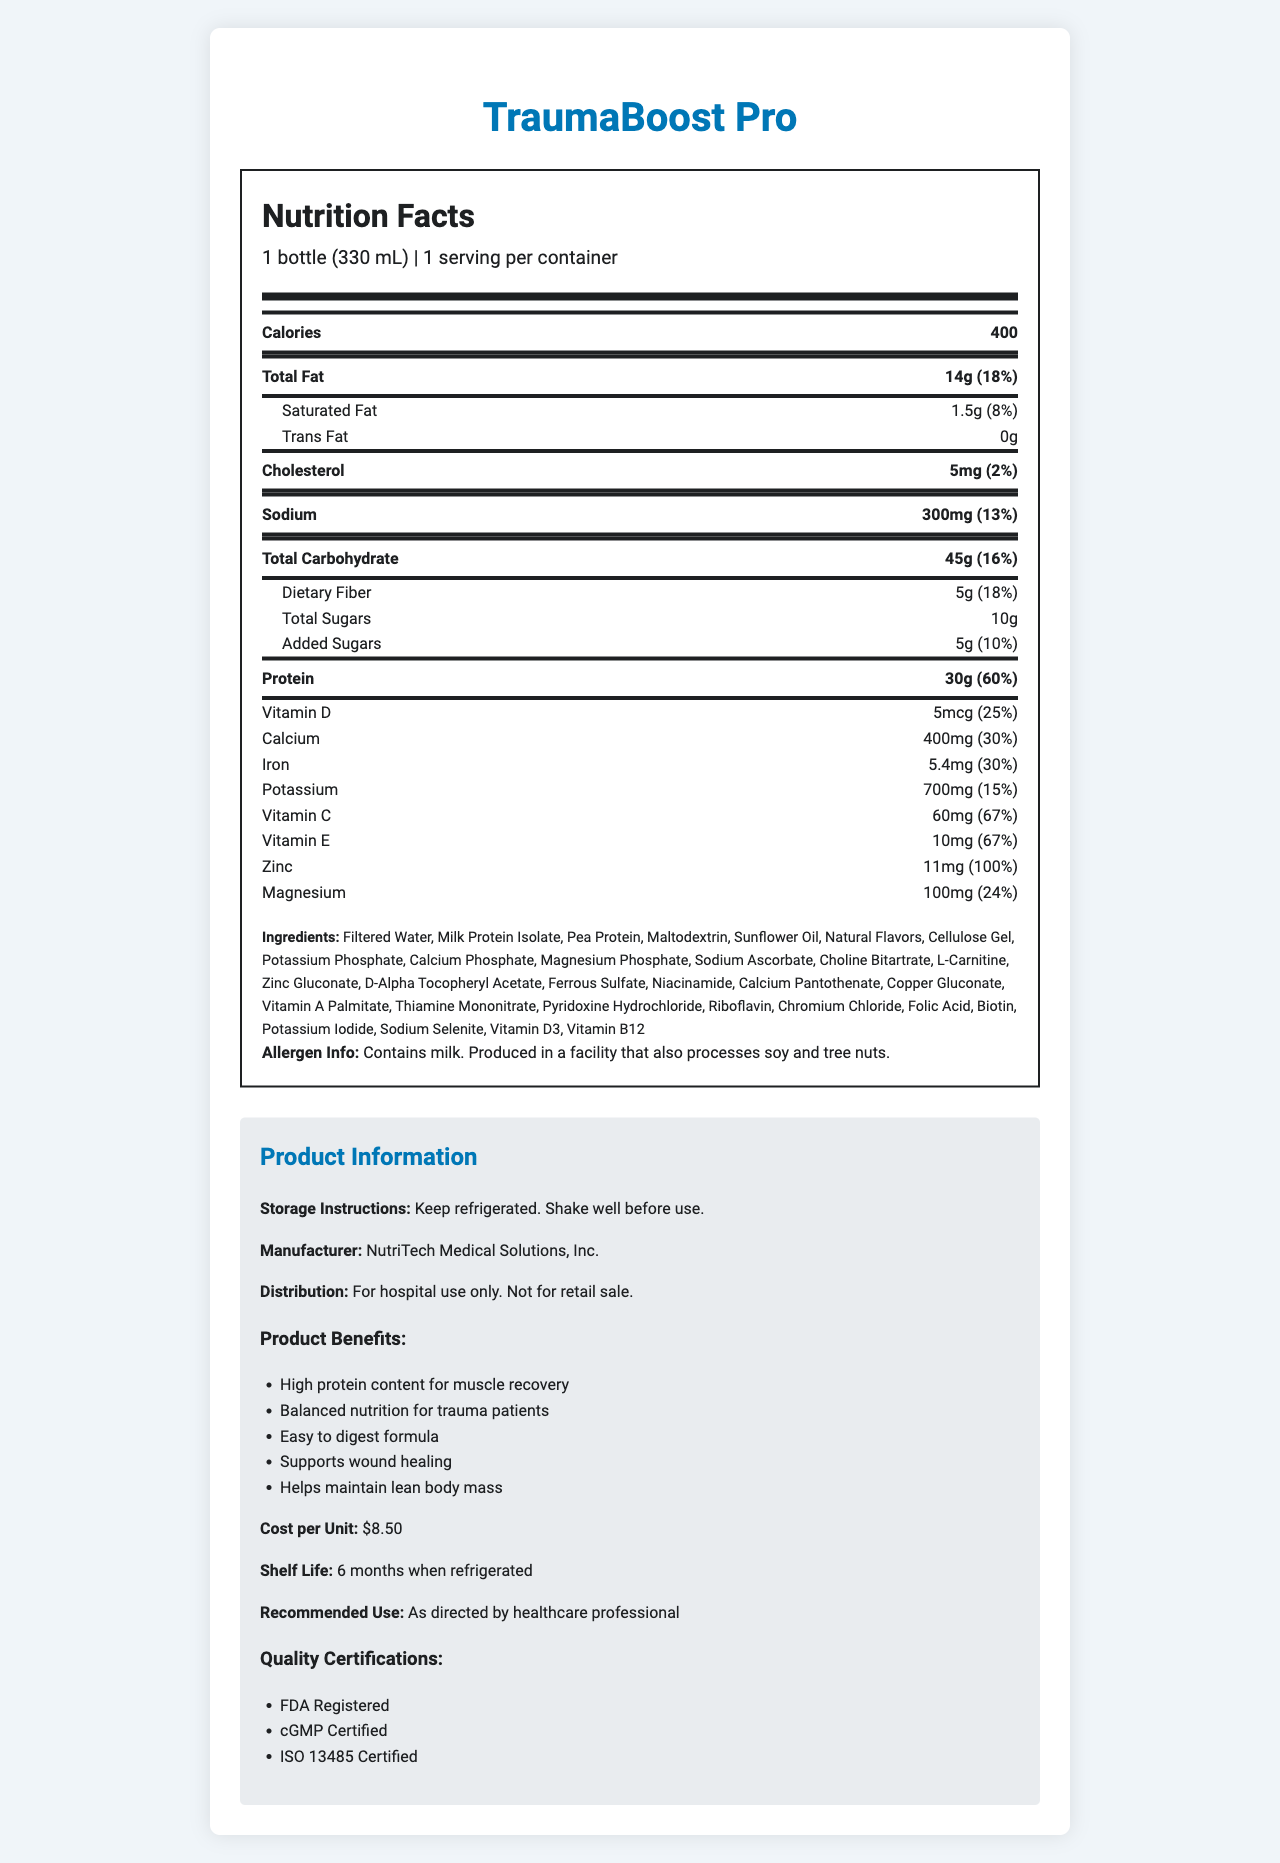What is the serving size of TraumaBoost Pro? The serving size is clearly listed at the top of the nutrition label as "1 bottle (330 mL)".
Answer: 1 bottle (330 mL) How many calories are in a single serving of TraumaBoost Pro? The calories are listed prominently in the main nutrient section of the nutrition label.
Answer: 400 calories What percentage of the daily value of protein does TraumaBoost Pro provide? The protein content is stated as "30g" which is 60% of the daily value as listed in the nutrition facts.
Answer: 60% Is TraumaBoost Pro suitable for individuals with a milk allergy? The allergen information states that the product contains milk.
Answer: No What is the cost per unit of TraumaBoost Pro? The cost per unit is listed in the product information section as "$8.50".
Answer: $8.50 Which vitamin has the highest daily value percentage in TraumaBoost Pro? A. Vitamin D B. Vitamin C C. Vitamin E D. Zinc Zinc has a daily value percentage of 100%, which is higher than the percentages of Vitamin D (25%), Vitamin C (67%), and Vitamin E (67%).
Answer: D. Zinc Which of the following is NOT an ingredient in TraumaBoost Pro? A. Maltodextrin B. Whey Protein C. Pea Protein D. Sunflower Oil The ingredients list includes Maltodextrin, Pea Protein, and Sunflower Oil, but not Whey Protein.
Answer: B. Whey Protein Does TraumaBoost Pro contain any trans fat? The nutrition facts state that the product contains "0g" of trans fat.
Answer: No Summarize the main nutritional benefits of TraumaBoost Pro. The product benefits section highlights the key advantages of using TraumaBoost Pro, including high protein for muscle recovery, balanced nutrition, and benefits for wound healing and lean body mass maintenance.
Answer: TraumaBoost Pro provides high protein content for muscle recovery, balanced nutrition for trauma patients, easy digestion, support for wound healing, and helps maintain lean body mass. Is TraumaBoost Pro intended for retail sale? The distribution information states that it is for hospital use only and not for retail sale.
Answer: No What certifications does TraumaBoost Pro have? The quality certifications listed in the product information section include FDA Registered, cGMP Certified, and ISO 13485 Certified.
Answer: FDA Registered, cGMP Certified, ISO 13485 Certified What type of facility is TraumaBoost Pro produced in? The document does not provide specific information on the type of facility, other than stating that it also processes soy and tree nuts.
Answer: Cannot be determined 